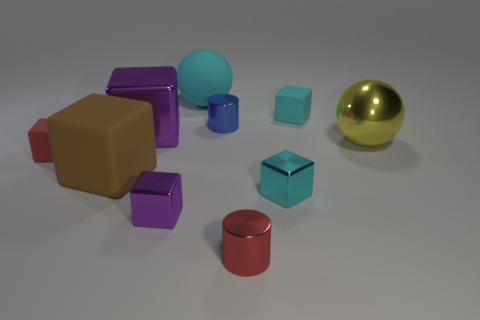Subtract all big metal cubes. How many cubes are left? 5 Subtract all blue cylinders. How many cylinders are left? 1 Subtract 1 cylinders. How many cylinders are left? 1 Subtract all gray balls. How many green cylinders are left? 0 Subtract all large metallic blocks. Subtract all big brown rubber cubes. How many objects are left? 8 Add 7 small cyan rubber cubes. How many small cyan rubber cubes are left? 8 Add 6 small yellow metallic blocks. How many small yellow metallic blocks exist? 6 Subtract 0 purple cylinders. How many objects are left? 10 Subtract all cubes. How many objects are left? 4 Subtract all cyan blocks. Subtract all red cylinders. How many blocks are left? 4 